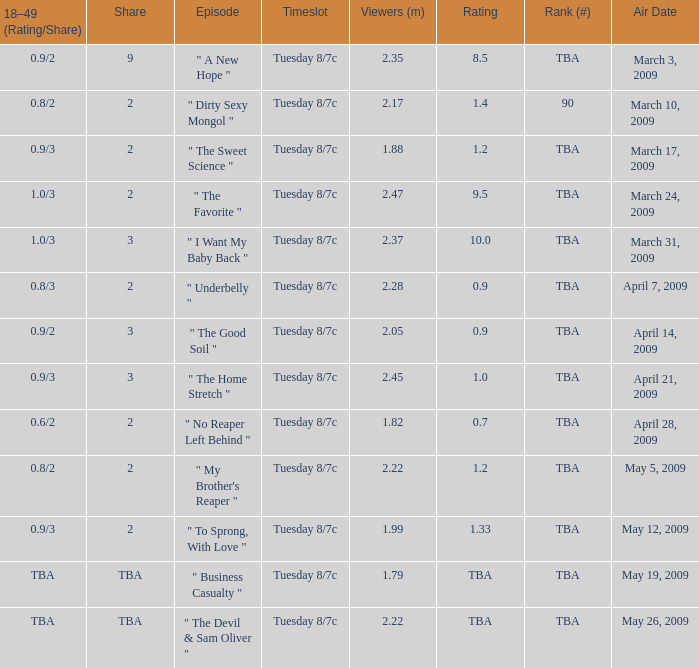8/3? 2.0. 